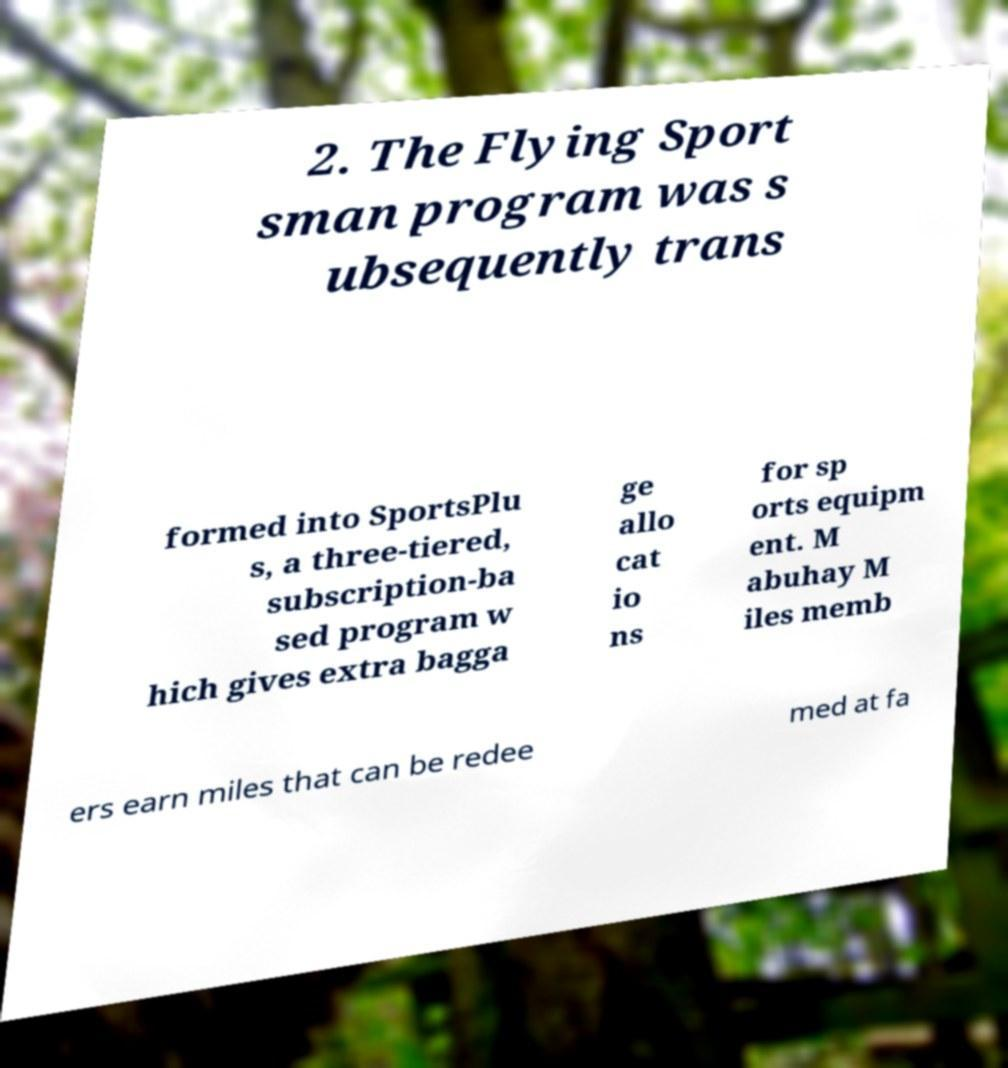What messages or text are displayed in this image? I need them in a readable, typed format. 2. The Flying Sport sman program was s ubsequently trans formed into SportsPlu s, a three-tiered, subscription-ba sed program w hich gives extra bagga ge allo cat io ns for sp orts equipm ent. M abuhay M iles memb ers earn miles that can be redee med at fa 